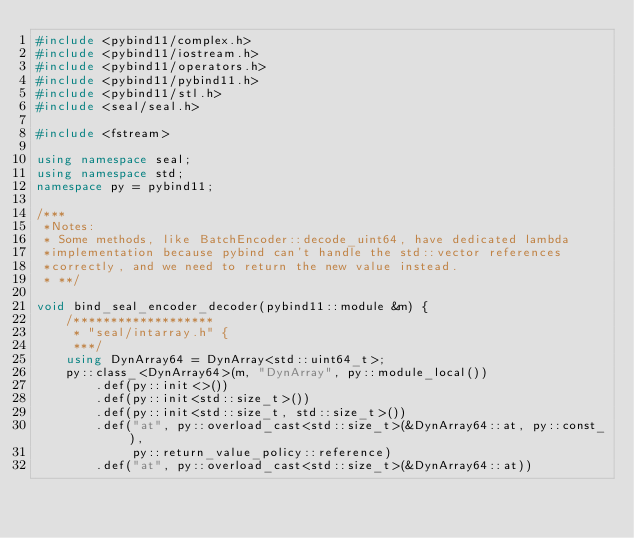Convert code to text. <code><loc_0><loc_0><loc_500><loc_500><_C++_>#include <pybind11/complex.h>
#include <pybind11/iostream.h>
#include <pybind11/operators.h>
#include <pybind11/pybind11.h>
#include <pybind11/stl.h>
#include <seal/seal.h>

#include <fstream>

using namespace seal;
using namespace std;
namespace py = pybind11;

/***
 *Notes:
 * Some methods, like BatchEncoder::decode_uint64, have dedicated lambda
 *implementation because pybind can't handle the std::vector references
 *correctly, and we need to return the new value instead.
 * **/

void bind_seal_encoder_decoder(pybind11::module &m) {
    /*******************
     * "seal/intarray.h" {
     ***/
    using DynArray64 = DynArray<std::uint64_t>;
    py::class_<DynArray64>(m, "DynArray", py::module_local())
        .def(py::init<>())
        .def(py::init<std::size_t>())
        .def(py::init<std::size_t, std::size_t>())
        .def("at", py::overload_cast<std::size_t>(&DynArray64::at, py::const_),
             py::return_value_policy::reference)
        .def("at", py::overload_cast<std::size_t>(&DynArray64::at))</code> 